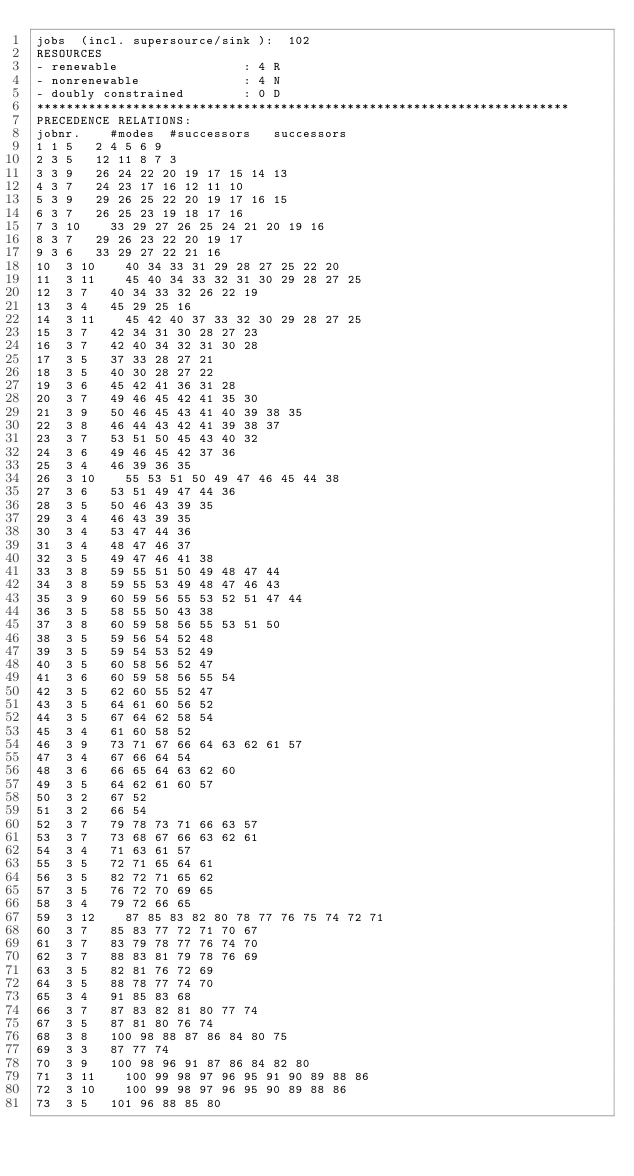<code> <loc_0><loc_0><loc_500><loc_500><_ObjectiveC_>jobs  (incl. supersource/sink ):	102
RESOURCES
- renewable                 : 4 R
- nonrenewable              : 4 N
- doubly constrained        : 0 D
************************************************************************
PRECEDENCE RELATIONS:
jobnr.    #modes  #successors   successors
1	1	5		2 4 5 6 9 
2	3	5		12 11 8 7 3 
3	3	9		26 24 22 20 19 17 15 14 13 
4	3	7		24 23 17 16 12 11 10 
5	3	9		29 26 25 22 20 19 17 16 15 
6	3	7		26 25 23 19 18 17 16 
7	3	10		33 29 27 26 25 24 21 20 19 16 
8	3	7		29 26 23 22 20 19 17 
9	3	6		33 29 27 22 21 16 
10	3	10		40 34 33 31 29 28 27 25 22 20 
11	3	11		45 40 34 33 32 31 30 29 28 27 25 
12	3	7		40 34 33 32 26 22 19 
13	3	4		45 29 25 16 
14	3	11		45 42 40 37 33 32 30 29 28 27 25 
15	3	7		42 34 31 30 28 27 23 
16	3	7		42 40 34 32 31 30 28 
17	3	5		37 33 28 27 21 
18	3	5		40 30 28 27 22 
19	3	6		45 42 41 36 31 28 
20	3	7		49 46 45 42 41 35 30 
21	3	9		50 46 45 43 41 40 39 38 35 
22	3	8		46 44 43 42 41 39 38 37 
23	3	7		53 51 50 45 43 40 32 
24	3	6		49 46 45 42 37 36 
25	3	4		46 39 36 35 
26	3	10		55 53 51 50 49 47 46 45 44 38 
27	3	6		53 51 49 47 44 36 
28	3	5		50 46 43 39 35 
29	3	4		46 43 39 35 
30	3	4		53 47 44 36 
31	3	4		48 47 46 37 
32	3	5		49 47 46 41 38 
33	3	8		59 55 51 50 49 48 47 44 
34	3	8		59 55 53 49 48 47 46 43 
35	3	9		60 59 56 55 53 52 51 47 44 
36	3	5		58 55 50 43 38 
37	3	8		60 59 58 56 55 53 51 50 
38	3	5		59 56 54 52 48 
39	3	5		59 54 53 52 49 
40	3	5		60 58 56 52 47 
41	3	6		60 59 58 56 55 54 
42	3	5		62 60 55 52 47 
43	3	5		64 61 60 56 52 
44	3	5		67 64 62 58 54 
45	3	4		61 60 58 52 
46	3	9		73 71 67 66 64 63 62 61 57 
47	3	4		67 66 64 54 
48	3	6		66 65 64 63 62 60 
49	3	5		64 62 61 60 57 
50	3	2		67 52 
51	3	2		66 54 
52	3	7		79 78 73 71 66 63 57 
53	3	7		73 68 67 66 63 62 61 
54	3	4		71 63 61 57 
55	3	5		72 71 65 64 61 
56	3	5		82 72 71 65 62 
57	3	5		76 72 70 69 65 
58	3	4		79 72 66 65 
59	3	12		87 85 83 82 80 78 77 76 75 74 72 71 
60	3	7		85 83 77 72 71 70 67 
61	3	7		83 79 78 77 76 74 70 
62	3	7		88 83 81 79 78 76 69 
63	3	5		82 81 76 72 69 
64	3	5		88 78 77 74 70 
65	3	4		91 85 83 68 
66	3	7		87 83 82 81 80 77 74 
67	3	5		87 81 80 76 74 
68	3	8		100 98 88 87 86 84 80 75 
69	3	3		87 77 74 
70	3	9		100 98 96 91 87 86 84 82 80 
71	3	11		100 99 98 97 96 95 91 90 89 88 86 
72	3	10		100 99 98 97 96 95 90 89 88 86 
73	3	5		101 96 88 85 80 </code> 